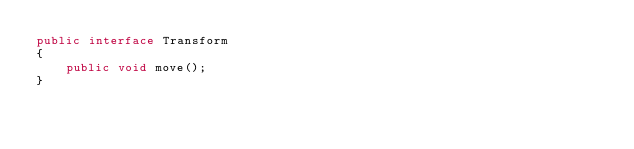<code> <loc_0><loc_0><loc_500><loc_500><_Java_>public interface Transform
{
	public void move();
}</code> 